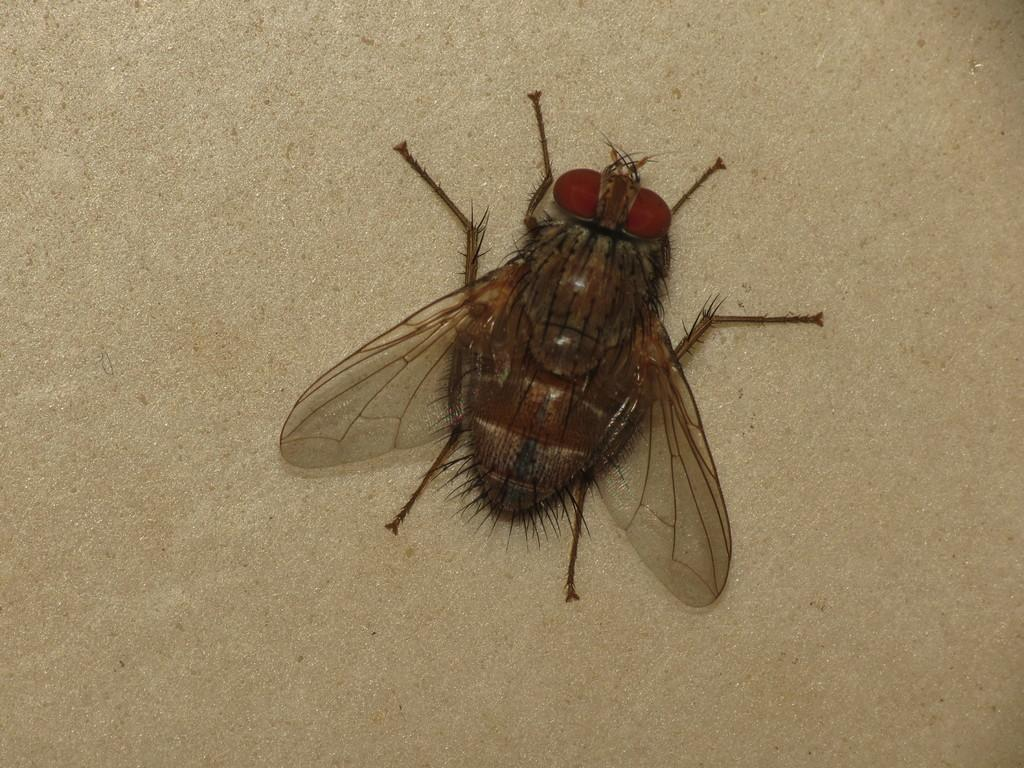What is the main subject of the image? The main subject of the image is a housefly. Where is the housefly located in the image? The housefly is in the centre of the image. What color is the surface on which the housefly is resting? The housefly is on a white color surface. What type of scarf is the housefly wearing in the image? There is no scarf present in the image, as the main subject is a housefly. Can you describe the fog in the image? There is no fog present in the image; it features a housefly on a white surface. 